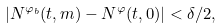<formula> <loc_0><loc_0><loc_500><loc_500>| N ^ { \varphi _ { b } } ( t , m ) - N ^ { \varphi } ( t , 0 ) | < \delta / 2 ,</formula> 